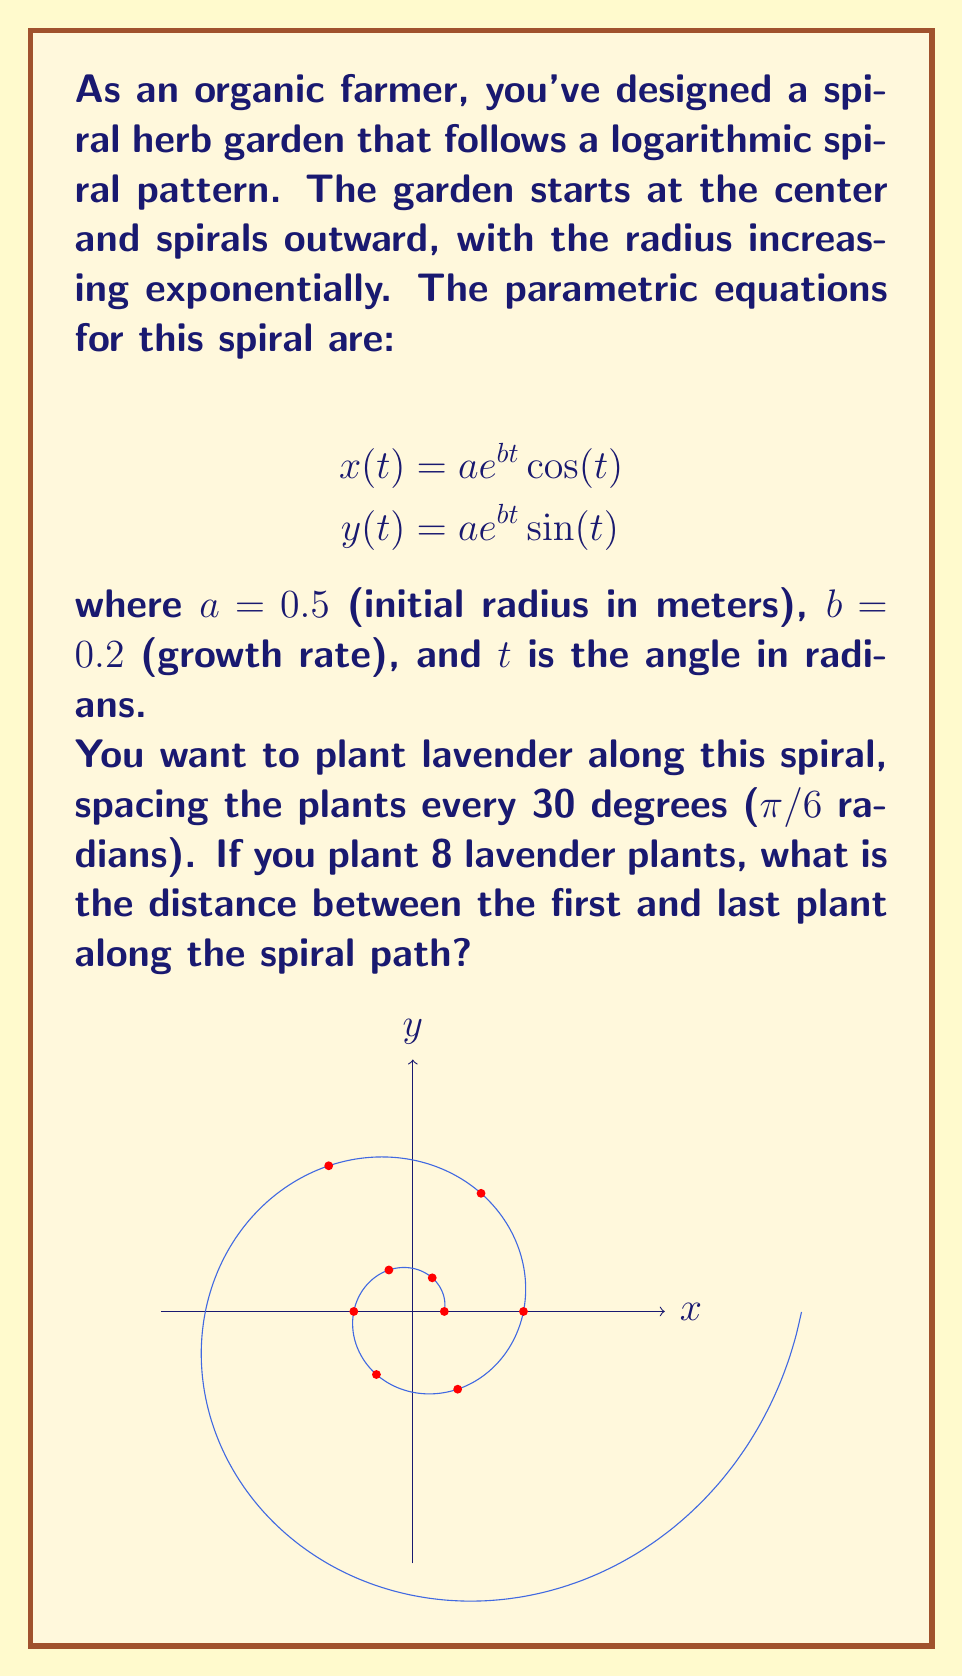Teach me how to tackle this problem. Let's approach this step-by-step:

1) First, we need to find the position of the first and last plant. 
   - The first plant is at t = 0
   - The last (8th) plant is at t = 7π/6 (as we start counting from 0)

2) To find the position of each plant, we use the parametric equations:
   For the first plant (t = 0):
   $$x(0) = 0.5e^{0.2(0)}\cos(0) = 0.5$$
   $$y(0) = 0.5e^{0.2(0)}\sin(0) = 0$$

   For the last plant (t = 7π/6):
   $$x(7π/6) = 0.5e^{0.2(7π/6)}\cos(7π/6) \approx -1.0458$$
   $$y(7π/6) = 0.5e^{0.2(7π/6)}\sin(7π/6) \approx -0.6038$$

3) To find the distance between these points, we can use the arc length formula for parametric equations:

   $$L = \int_{0}^{7π/6} \sqrt{(\frac{dx}{dt})^2 + (\frac{dy}{dt})^2} dt$$

4) We need to find dx/dt and dy/dt:
   $$\frac{dx}{dt} = ae^{bt}(b\cos(t) - \sin(t))$$
   $$\frac{dy}{dt} = ae^{bt}(b\sin(t) + \cos(t))$$

5) Substituting these into the arc length formula:

   $$L = \int_{0}^{7π/6} \sqrt{(ae^{bt}(b\cos(t) - \sin(t)))^2 + (ae^{bt}(b\sin(t) + \cos(t)))^2} dt$$

6) Simplifying inside the square root:

   $$L = \int_{0}^{7π/6} \sqrt{a^2e^{2bt}((b\cos(t) - \sin(t))^2 + (b\sin(t) + \cos(t))^2)} dt$$
   $$L = \int_{0}^{7π/6} \sqrt{a^2e^{2bt}(b^2\cos^2(t) - 2b\cos(t)\sin(t) + \sin^2(t) + b^2\sin^2(t) + 2b\sin(t)\cos(t) + \cos^2(t))} dt$$
   $$L = \int_{0}^{7π/6} \sqrt{a^2e^{2bt}(b^2(\cos^2(t) + \sin^2(t)) + (\sin^2(t) + \cos^2(t)))} dt$$
   $$L = \int_{0}^{7π/6} \sqrt{a^2e^{2bt}(b^2 + 1)} dt$$
   $$L = a\sqrt{b^2 + 1}\int_{0}^{7π/6} e^{bt} dt$$

7) Evaluating the integral:

   $$L = \frac{a\sqrt{b^2 + 1}}{b}[e^{bt}]_{0}^{7π/6}$$
   $$L = \frac{a\sqrt{b^2 + 1}}{b}(e^{7bπ/6} - 1)$$

8) Substituting the values a = 0.5, b = 0.2:

   $$L = \frac{0.5\sqrt{0.2^2 + 1}}{0.2}(e^{7(0.2)π/6} - 1) \approx 2.3815$$

Therefore, the distance between the first and last plant along the spiral path is approximately 2.3815 meters.
Answer: $2.3815$ meters 